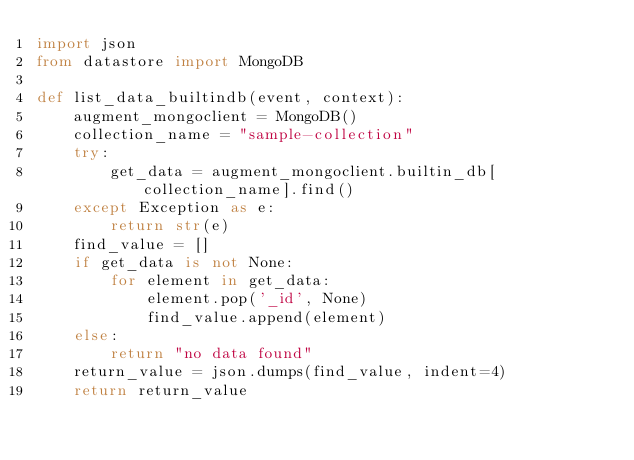Convert code to text. <code><loc_0><loc_0><loc_500><loc_500><_Python_>import json
from datastore import MongoDB

def list_data_builtindb(event, context):
    augment_mongoclient = MongoDB()
    collection_name = "sample-collection"
    try:
        get_data = augment_mongoclient.builtin_db[collection_name].find()
    except Exception as e:
        return str(e)
    find_value = []
    if get_data is not None:
        for element in get_data:
            element.pop('_id', None)
            find_value.append(element)
    else:
        return "no data found"
    return_value = json.dumps(find_value, indent=4)
    return return_value
</code> 